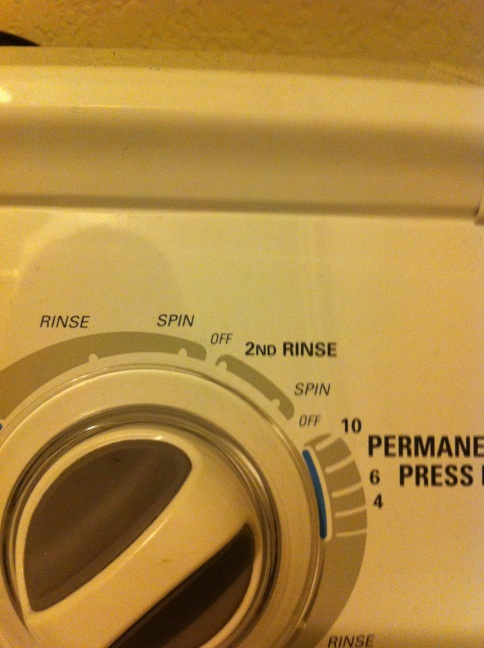Can you explain the different settings on this washing machine? Sure! This washing machine has multiple settings indicated by the arrows. The 'Rinse' setting helps to rinse clothes with water to remove detergent residue. 'Spin' extracts excess water from the clothes by spinning them at high speeds. 'Off' stops the machine. '2nd Rinse' is an additional rinse cycle to ensure any remaining detergent is removed from the clothes. 